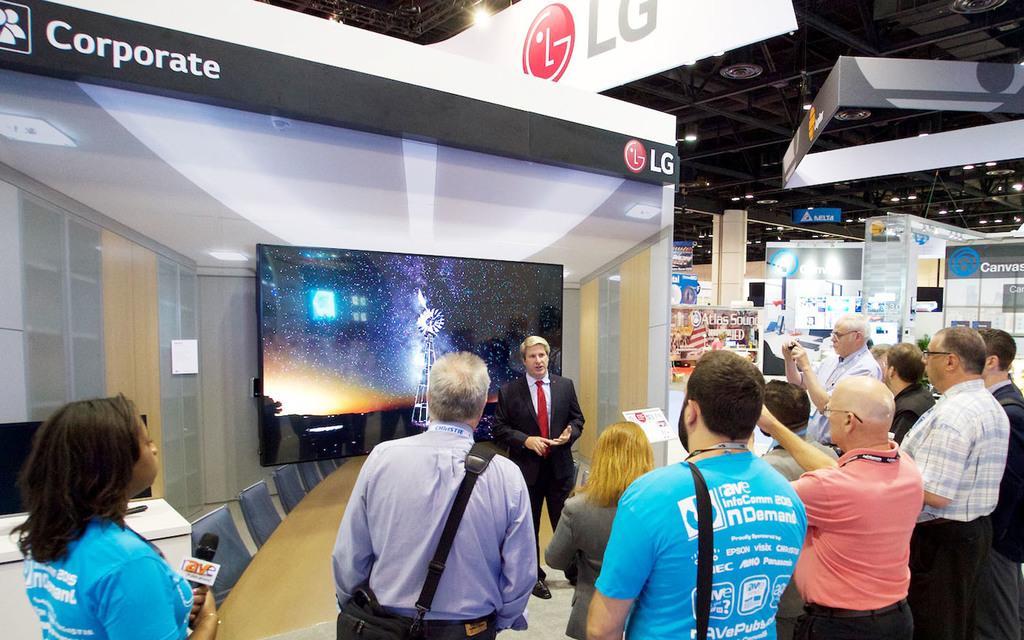Please provide a concise description of this image. In this picture we can see some people are standing, a woman at the left bottom is holding a mike, on the left side we can see some chairs and two screens, in the background there are some hoardings and boards, we can see some lights at the top of the picture, we can also see a pillar in the background. 